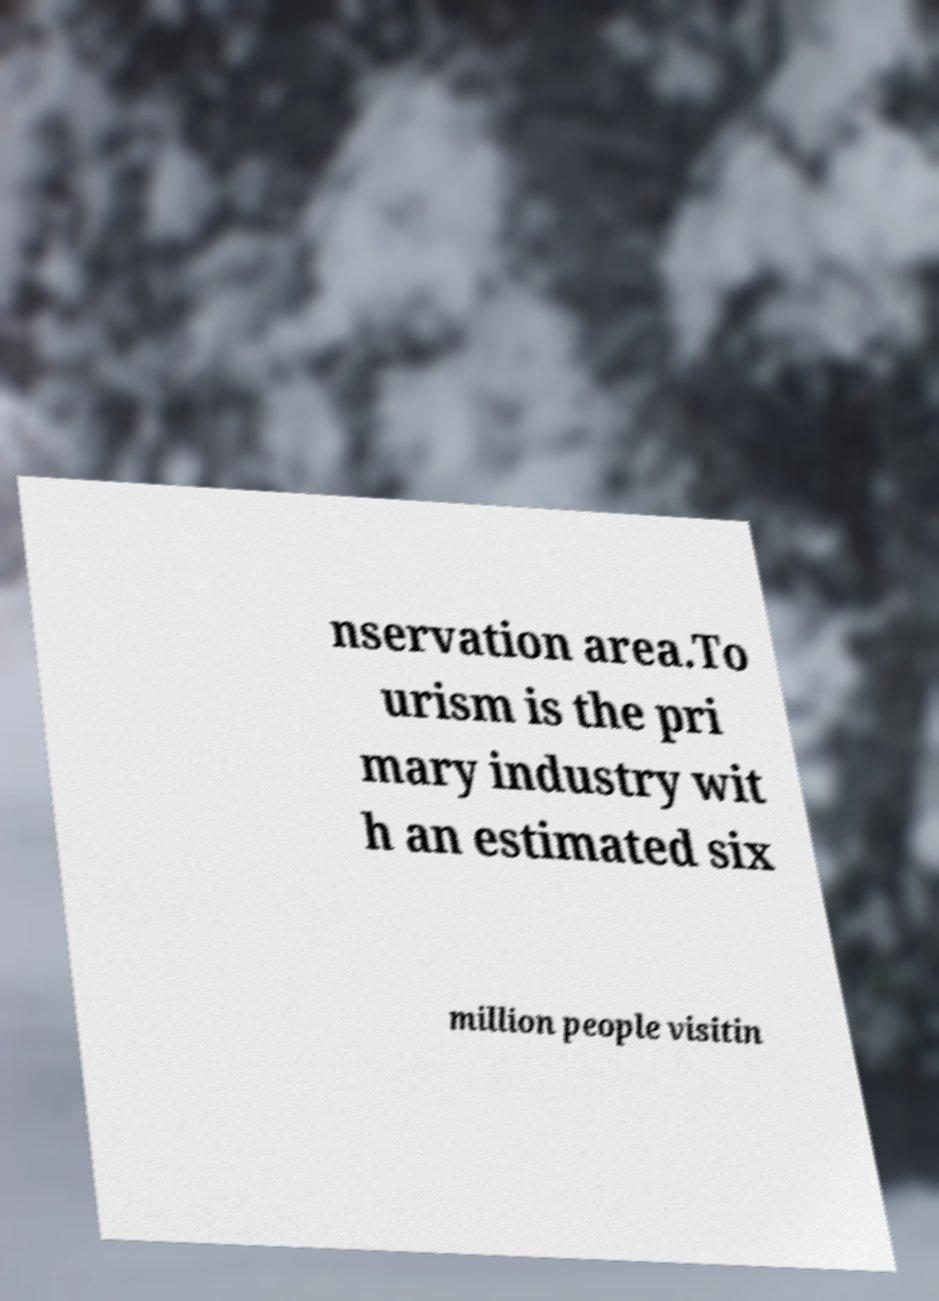Please read and relay the text visible in this image. What does it say? nservation area.To urism is the pri mary industry wit h an estimated six million people visitin 